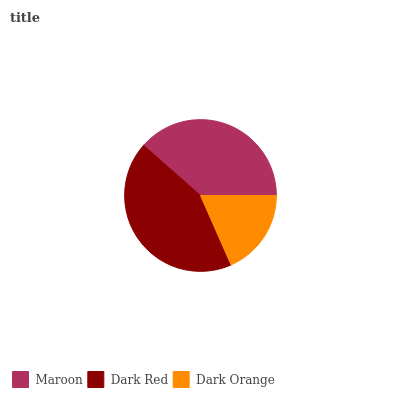Is Dark Orange the minimum?
Answer yes or no. Yes. Is Dark Red the maximum?
Answer yes or no. Yes. Is Dark Red the minimum?
Answer yes or no. No. Is Dark Orange the maximum?
Answer yes or no. No. Is Dark Red greater than Dark Orange?
Answer yes or no. Yes. Is Dark Orange less than Dark Red?
Answer yes or no. Yes. Is Dark Orange greater than Dark Red?
Answer yes or no. No. Is Dark Red less than Dark Orange?
Answer yes or no. No. Is Maroon the high median?
Answer yes or no. Yes. Is Maroon the low median?
Answer yes or no. Yes. Is Dark Orange the high median?
Answer yes or no. No. Is Dark Red the low median?
Answer yes or no. No. 